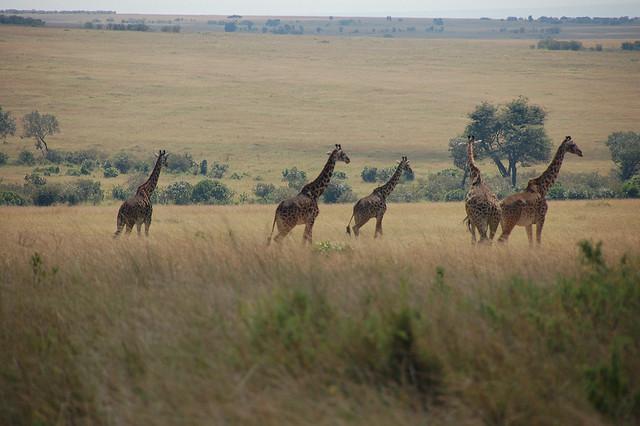Which giraffe is farthest from this small herd?
Pick the correct solution from the four options below to address the question.
Options: Far right, middle left, far left, middle right. Far left. 